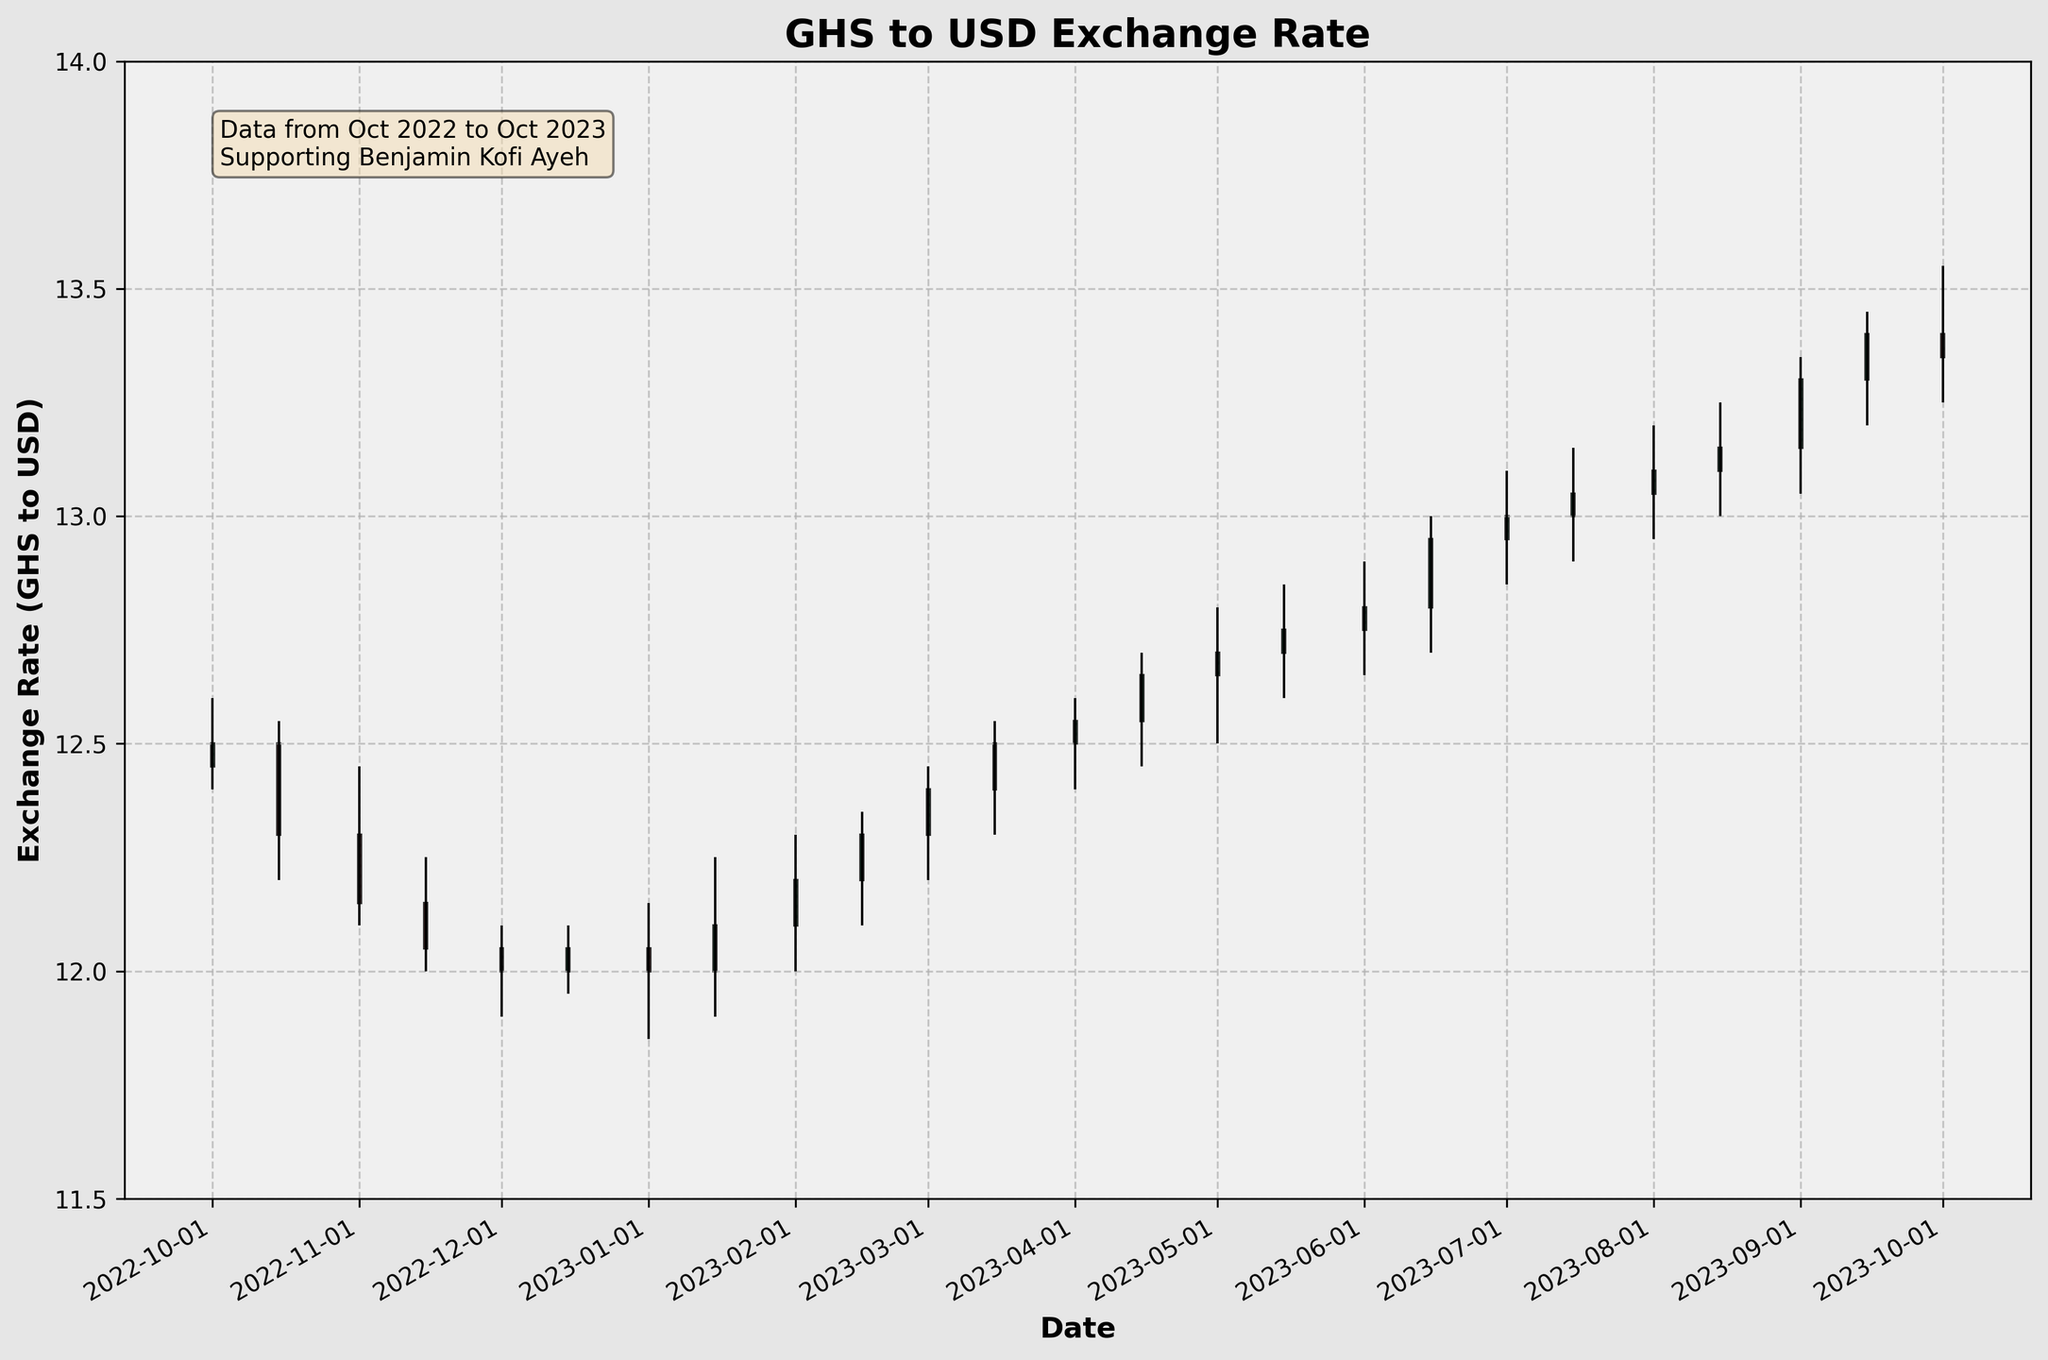What is the title of the plot? The title is typically found at the top of the figure where it describes the main focus of the plot. In this case, it reads “GHS to USD Exchange Rate”.
Answer: GHS to USD Exchange Rate How many data points are represented in the plot? To determine the number of data points, count the distinct candlesticks in the plot, each representing a specific date.
Answer: 24 What is the highest recorded exchange rate in the data? Look for the highest point on the y-axis values where the upper wick of any candlestick reaches.
Answer: 13.45 What period does the plot cover? Examine the x-axis labels for the starting and ending dates to understand the time span covered by the plot.
Answer: October 2022 to October 2023 What was the closing exchange rate on May 1, 2023? Identify the candlestick corresponding to May 1, and observe the top or bottom edge that represents the closing rate.
Answer: 12.70 Which date had the smallest range between the high and low rates? Compare the lengths of the vertical lines (representing the high and low rates) for each candlestick to find the shortest one.
Answer: December 1, 2022 How did the exchange rate change from January 1, 2023, to January 15, 2023? Note the closing rate on January 1 and January 15 to observe the change.
Answer: Increased from 12.00 to 12.10 What was the lowest closing rate in the given period? Find the lowest point on the bottom edge of the candlesticks, which represents the closing rates.
Answer: 12.00 On which date did the exchange rate close lower than it opened, but still had the highest close among all such dates? Identify the red (downward) candlesticks and compare their closing rates to find the highest one.
Answer: October 1, 2023 How many times did the closing rate increase consecutively for more than two periods? Identify sequences where the closing rate increases in more than two consecutive candlesticks. Count these sequences.
Answer: 2 What is the average closing rate over the entire period? Sum the closing rates from each candlestick and divide by the total number of data points. For detailed steps: (12.50 + 12.30 + 12.15 + 12.05 + 12.00 + 12.05 + 12.00 + 12.10 + 12.20 + 12.30 + 12.40 + 12.50 + 12.55 + 12.65 + 12.70 + 12.75 + 12.80 + 12.95 + 13.00 + 13.05 + 13.10 + 13.15 + 13.30 + 13.40 + 13.35) / 24 = 12.56.
Answer: 12.56 